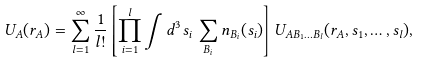Convert formula to latex. <formula><loc_0><loc_0><loc_500><loc_500>U _ { A } ( r _ { A } ) = \sum _ { l = 1 } ^ { \infty } \frac { 1 } { l ! } \left [ \prod _ { i = 1 } ^ { l } \int d ^ { 3 } s _ { i } \, \sum _ { B _ { i } } n _ { B _ { i } } ( s _ { i } ) \right ] U _ { A B _ { 1 } \dots B _ { l } } ( r _ { A } , s _ { 1 } , \dots , s _ { l } ) ,</formula> 